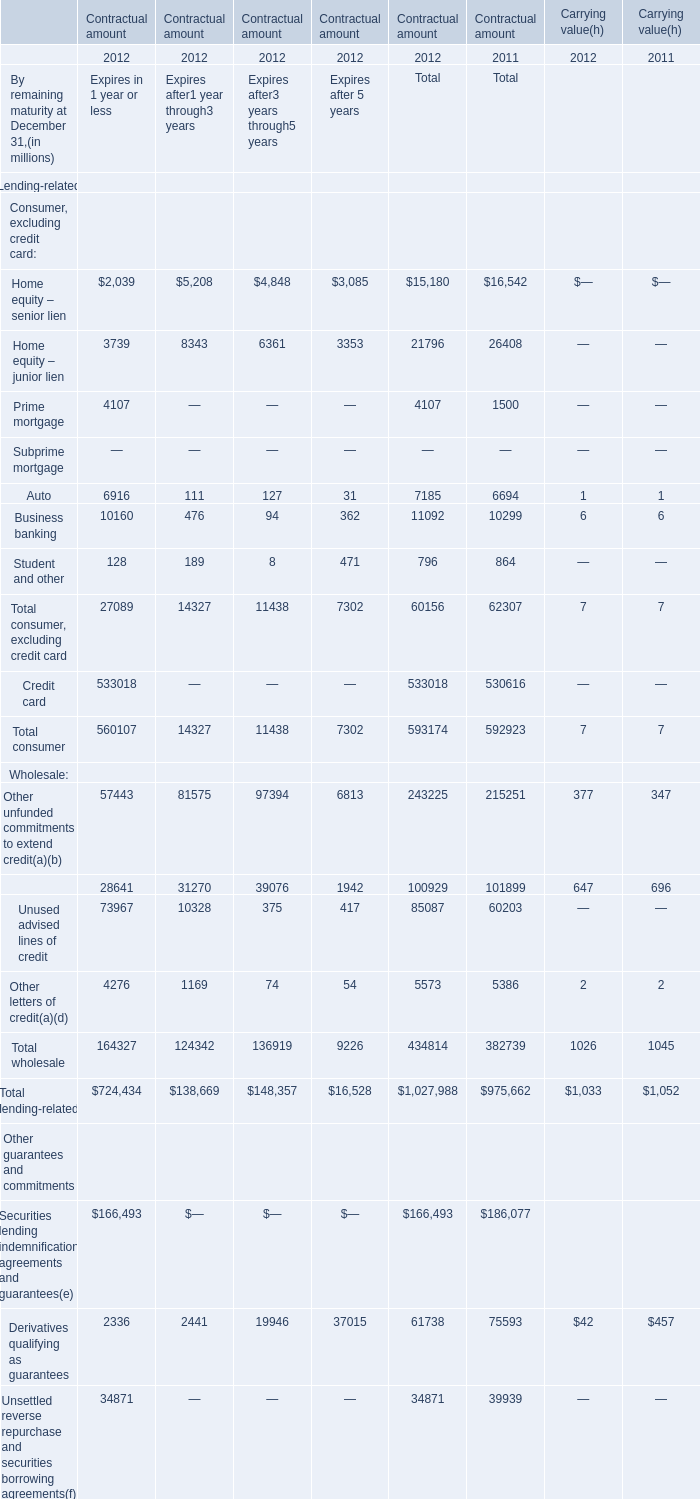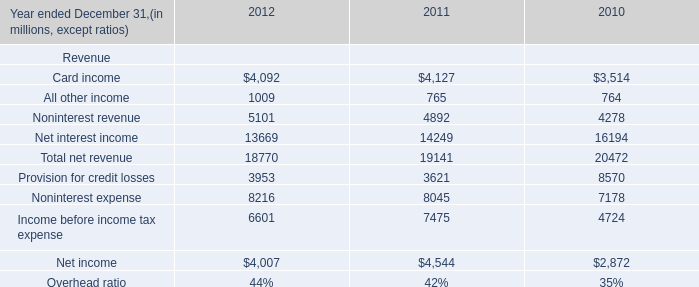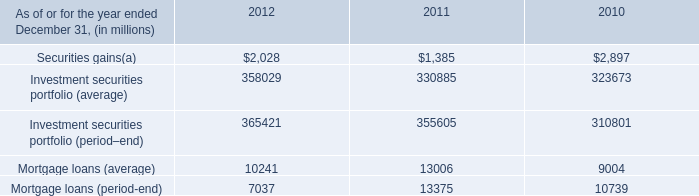would would 2011 net income have been without the private equity segment ( in millions ) ? 
Computations: (822 - 391)
Answer: 431.0. 